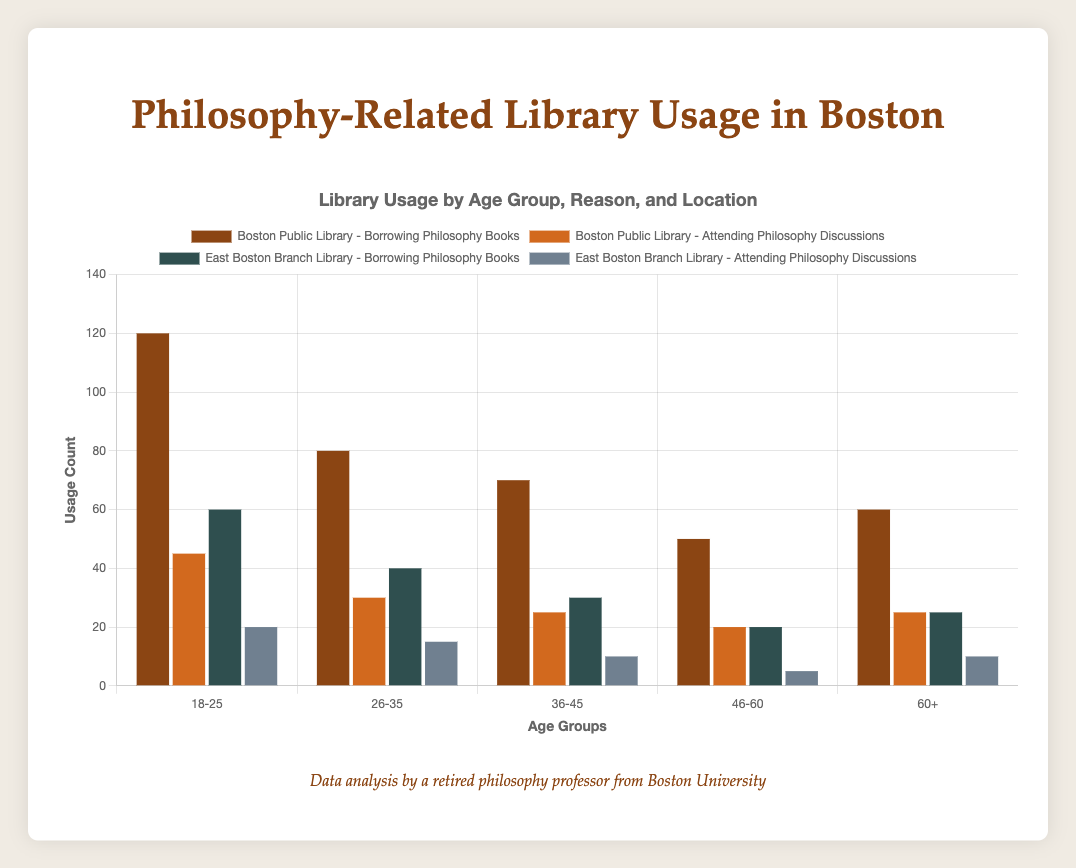What age group has the highest usage count for borrowing philosophy books at the Boston Public Library? To determine this, look at the bars representing different age groups and their respective counts for borrowing philosophy books at the Boston Public Library (brown bar). The 18-25 age group has the highest count.
Answer: 18-25 How does the usage count for attending philosophy discussions compare between the 26-35 and 60+ age groups at the East Boston Branch Library? Compare the heights of the bars for attending philosophy discussions at the East Boston Branch Library (grey bar) for the 26-35 and 60+ age groups. The 26-35 age group has a count of 15, while the 60+ age group has a count of 10.
Answer: 26-35 > 60+ What is the total usage count for borrowing philosophy books at the Boston Public Library across all age groups? Sum the usage counts for borrowing philosophy books at the Boston Public Library (brown bar) across all age groups: 120 (18-25) + 80 (26-35) + 70 (36-45) + 50 (46-60) + 60 (60+). The total is 380.
Answer: 380 Which age group has the smallest difference in usage count between borrowing philosophy books and attending philosophy discussions at the Boston Public Library? Calculate the difference between the usage counts for borrowing books and attending discussions for each age group at the Boston Public Library (brown and orange bars). The smallest difference is for the 46-60 age group, with a difference of 30 (50-20).
Answer: 46-60 What is the average usage count for attending philosophy discussions at both libraries for the 36-45 age group? Add the usage counts for attending philosophy discussions for the 36-45 age group at both libraries (Boston Public Library and East Boston Branch Library) and then divide by 2: (25 + 10) / 2 = 17.5.
Answer: 17.5 